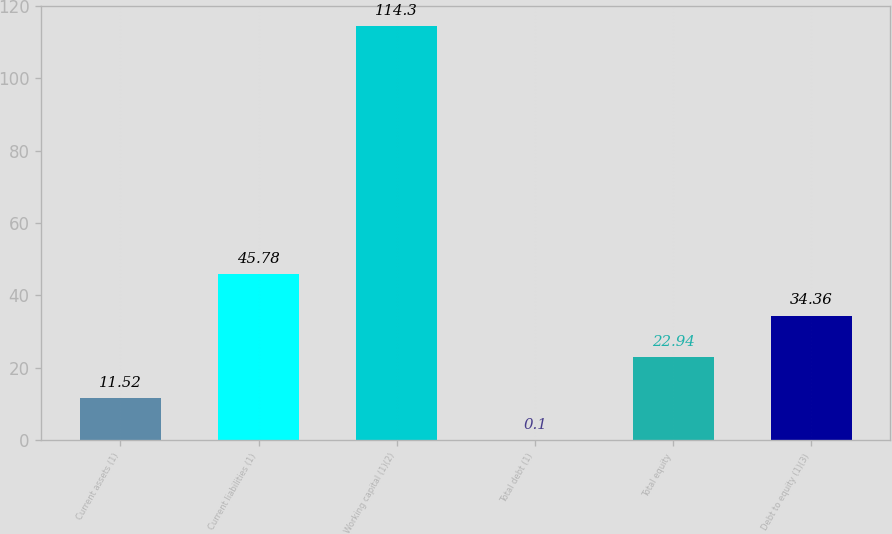Convert chart to OTSL. <chart><loc_0><loc_0><loc_500><loc_500><bar_chart><fcel>Current assets (1)<fcel>Current liabilities (1)<fcel>Working capital (1)(2)<fcel>Total debt (1)<fcel>Total equity<fcel>Debt to equity (1)(3)<nl><fcel>11.52<fcel>45.78<fcel>114.3<fcel>0.1<fcel>22.94<fcel>34.36<nl></chart> 